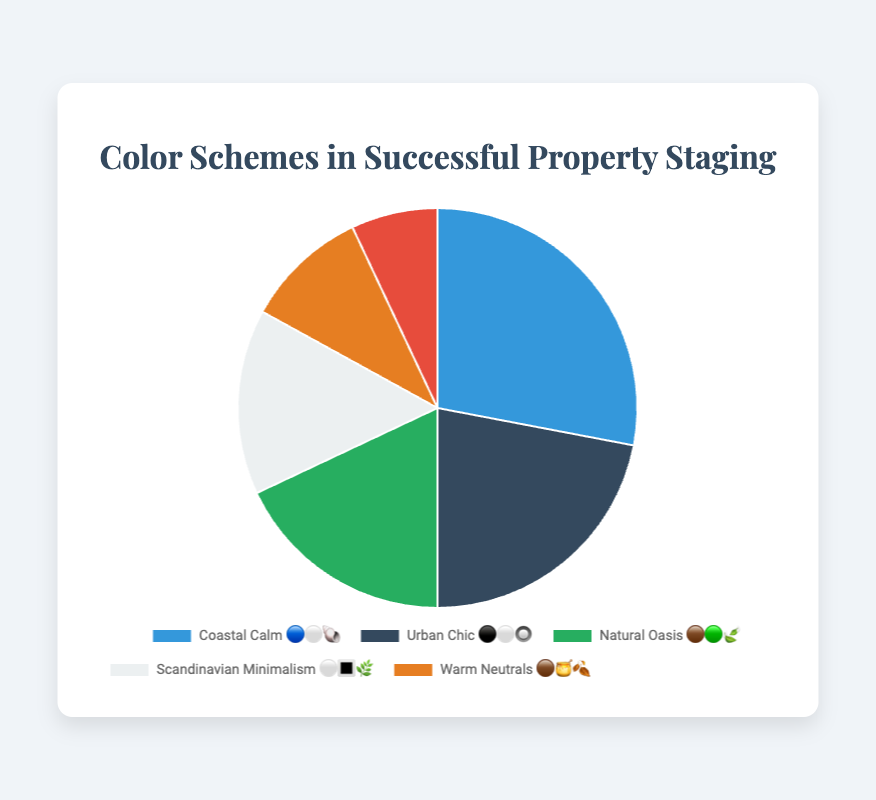What is the most common color scheme used in successful property staging projects? By looking at the data, "Coastal Calm" represents the highest percentage at 28%.
Answer: Coastal Calm Which color scheme is represented by the palette "🟤🟢🍃"? According to the data, the palette "🟤🟢🍃" corresponds to the color scheme "Natural Oasis".
Answer: Natural Oasis How much more popular is "Urban Chic" compared to "Bold Accent"? "Urban Chic" has a percentage of 22%, while "Bold Accent" is 7%. The difference is 22% - 7% = 15%.
Answer: 15% What percentage of staging projects use either "Scandinavian Minimalism" or "Warm Neutrals"? "Scandinavian Minimalism" is 15% and "Warm Neutrals" is 10%, so the total is 15% + 10% = 25%.
Answer: 25% Which color scheme has the lowest usage percentage? The data shows that "Bold Accent" has the lowest percentage at 7%.
Answer: Bold Accent How many color schemes are represented in the chart? There are six different color schemes represented in the data.
Answer: 6 What is the combined percentage for "Natural Oasis", "Scandinavian Minimalism", and "Warm Neutrals"? "Natural Oasis" is 18%, "Scandinavian Minimalism" is 15%, and "Warm Neutrals" is 10%, so the combined percentage is 18% + 15% + 10% = 43%.
Answer: 43% Which color scheme uses the palette "⚪️🔳🌿"? The data indicates that "Scandinavian Minimalism" uses the palette "⚪️🔳🌿".
Answer: Scandinavian Minimalism What is the average percentage of all the color schemes presented? Adding up all the percentages: 28% + 22% + 18% + 15% + 10% + 7% = 100%. There are 6 schemes, so the average is 100% / 6 = 16.67%.
Answer: 16.67% Out of all color schemes, which two have the highest combined percentage? The two highest percentages are "Coastal Calm" (28%) and "Urban Chic" (22%), so their combined percentage is 28% + 22% = 50%.
Answer: Coastal Calm and Urban Chic 